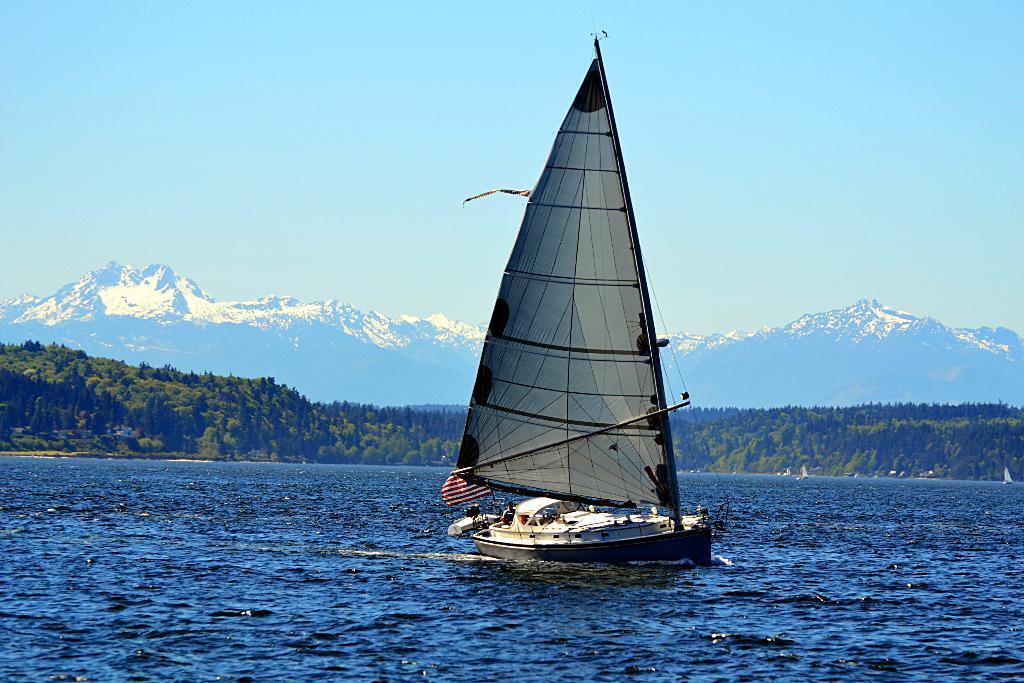In one or two sentences, can you explain what this image depicts? In the picture I can see the sailing ship in the water and I can see a person and a flag in the ship. In the background, I can see the mountains and trees. There are clouds in the sky. 